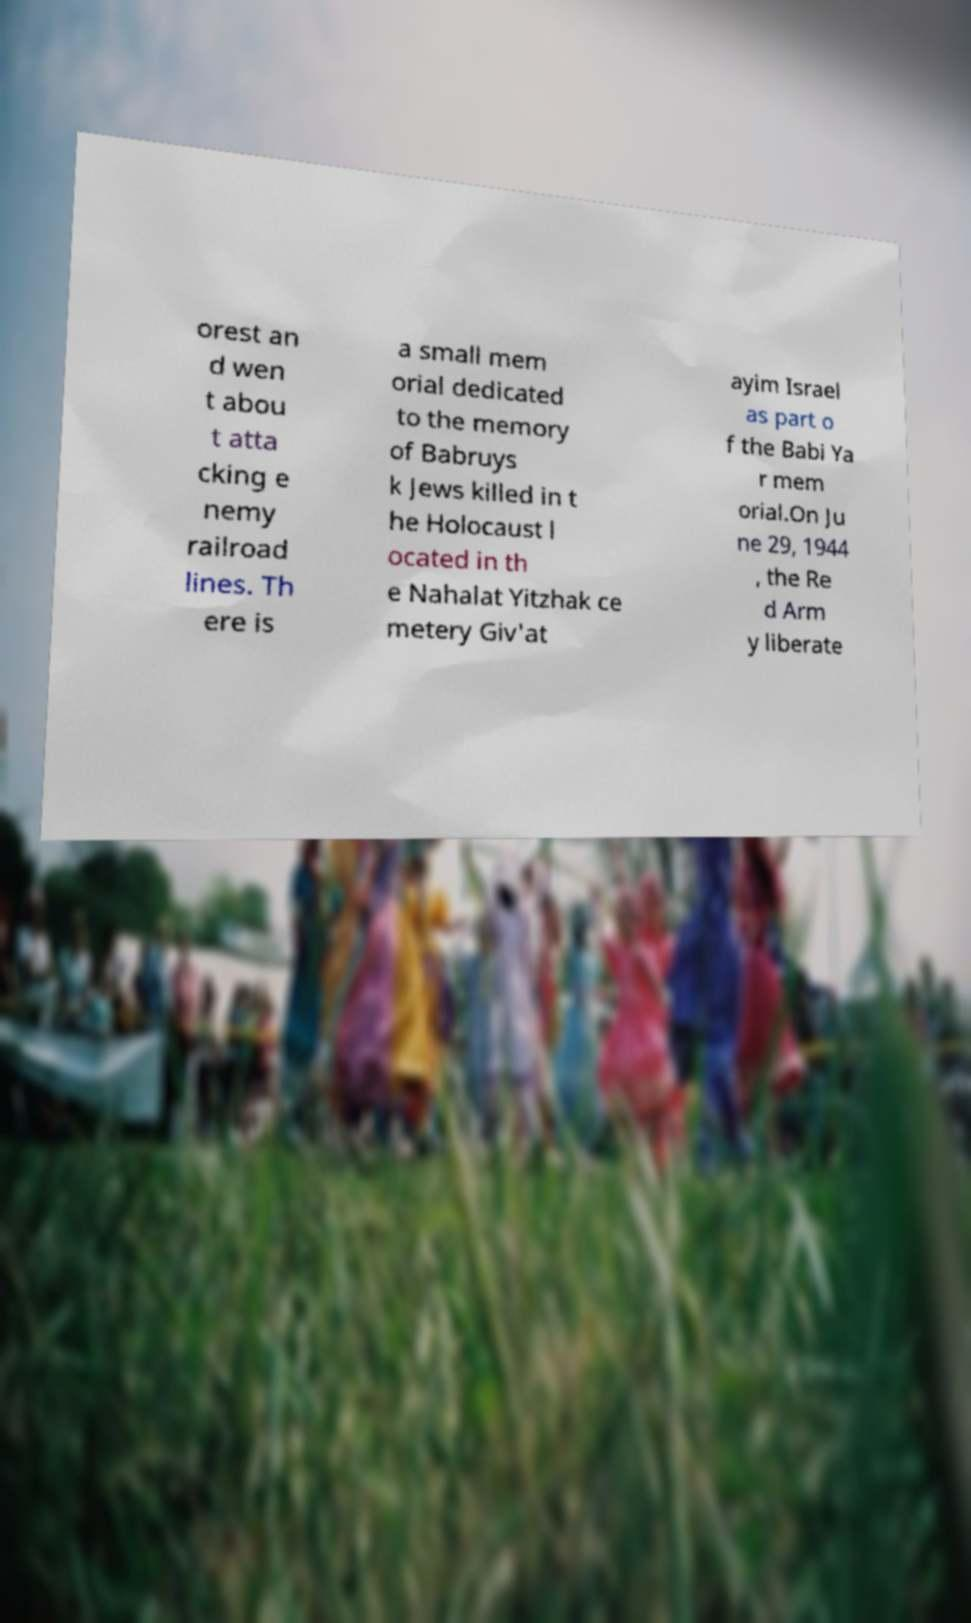Could you extract and type out the text from this image? orest an d wen t abou t atta cking e nemy railroad lines. Th ere is a small mem orial dedicated to the memory of Babruys k Jews killed in t he Holocaust l ocated in th e Nahalat Yitzhak ce metery Giv'at ayim Israel as part o f the Babi Ya r mem orial.On Ju ne 29, 1944 , the Re d Arm y liberate 